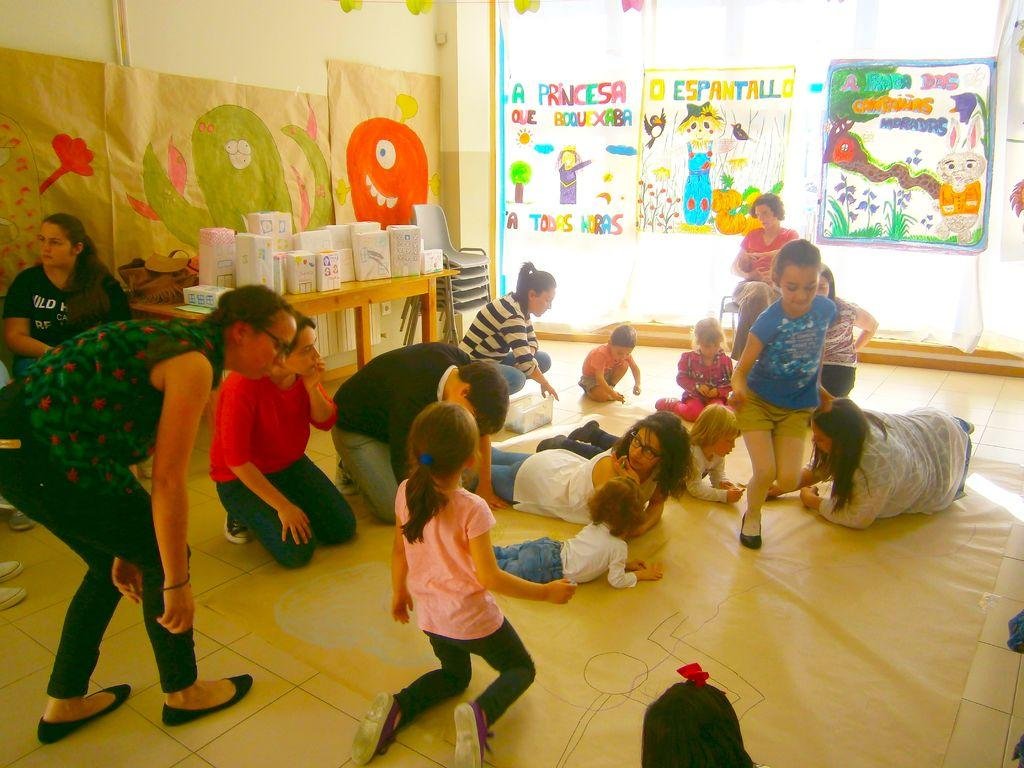What is the main focus of the image? The main focus of the image is the many persons on the mat in the center. What can be seen in the background of the image? In the background, there are chairs, a table, objects, posters, and a wall. How many persons are on the mat in the image? The number of persons on the mat is not specified, but there are many. What type of knot is being tied by the person in the image? There is no person tying a knot in the image; the main focus is on the many persons on the mat. What facial expression does the person in the image have? There is no person's face visible in the image; the focus is on the group of persons on the mat. 